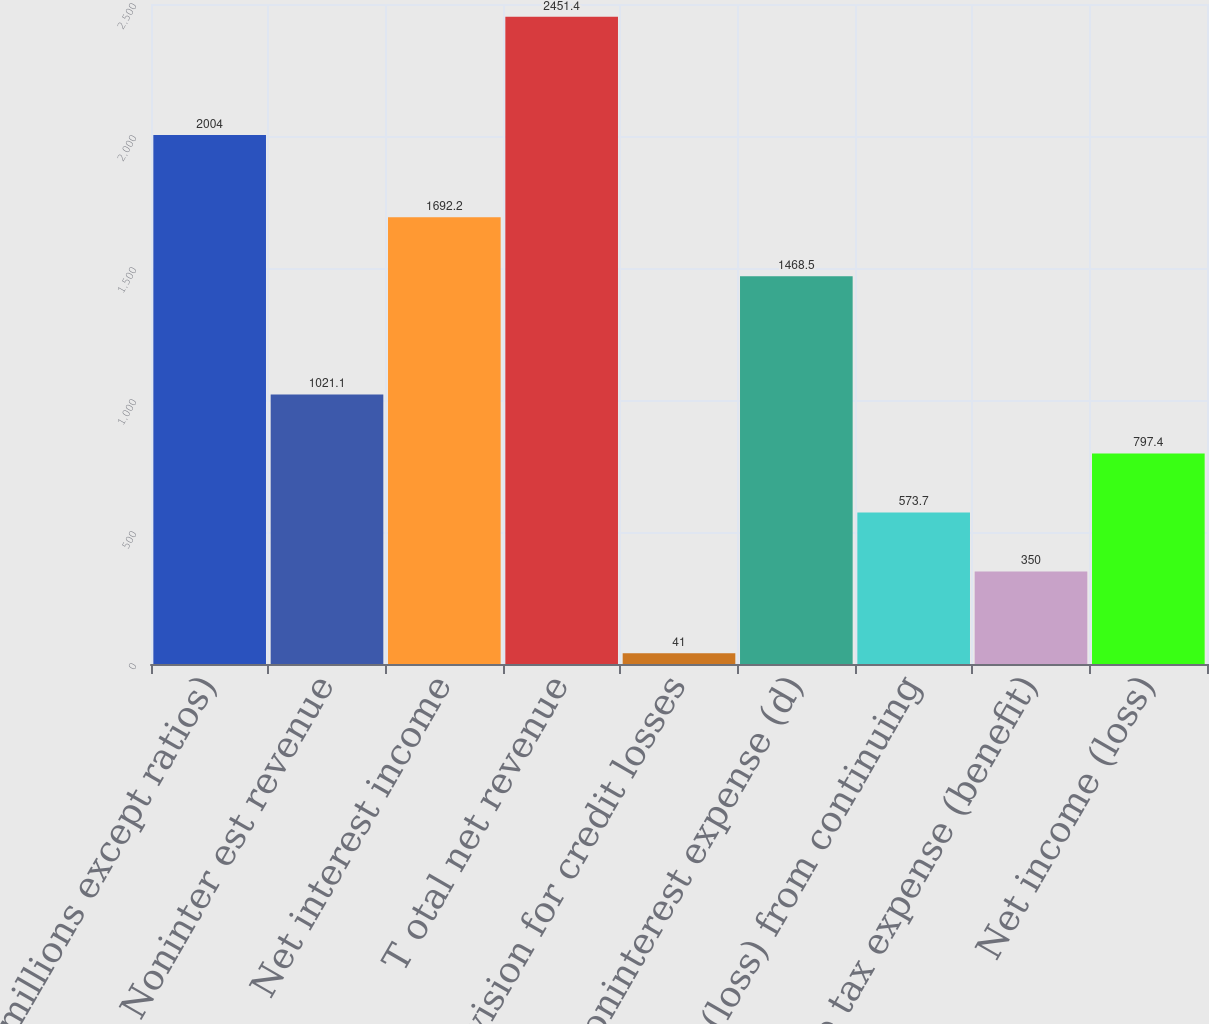Convert chart. <chart><loc_0><loc_0><loc_500><loc_500><bar_chart><fcel>(in millions except ratios)<fcel>Noninter est revenue<fcel>Net interest income<fcel>T otal net revenue<fcel>Provision for credit losses<fcel>Noninterest expense (d)<fcel>Income (loss) from continuing<fcel>Income tax expense (benefit)<fcel>Net income (loss)<nl><fcel>2004<fcel>1021.1<fcel>1692.2<fcel>2451.4<fcel>41<fcel>1468.5<fcel>573.7<fcel>350<fcel>797.4<nl></chart> 